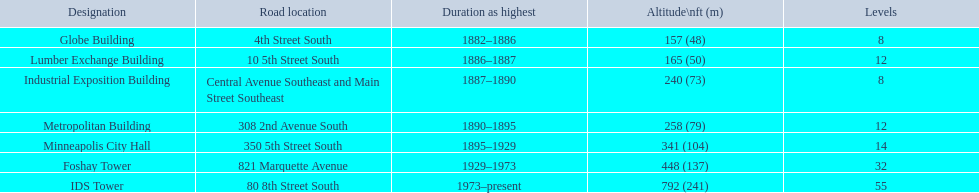What are all the building names? Globe Building, Lumber Exchange Building, Industrial Exposition Building, Metropolitan Building, Minneapolis City Hall, Foshay Tower, IDS Tower. And their heights? 157 (48), 165 (50), 240 (73), 258 (79), 341 (104), 448 (137), 792 (241). Between metropolitan building and lumber exchange building, which is taller? Metropolitan Building. 